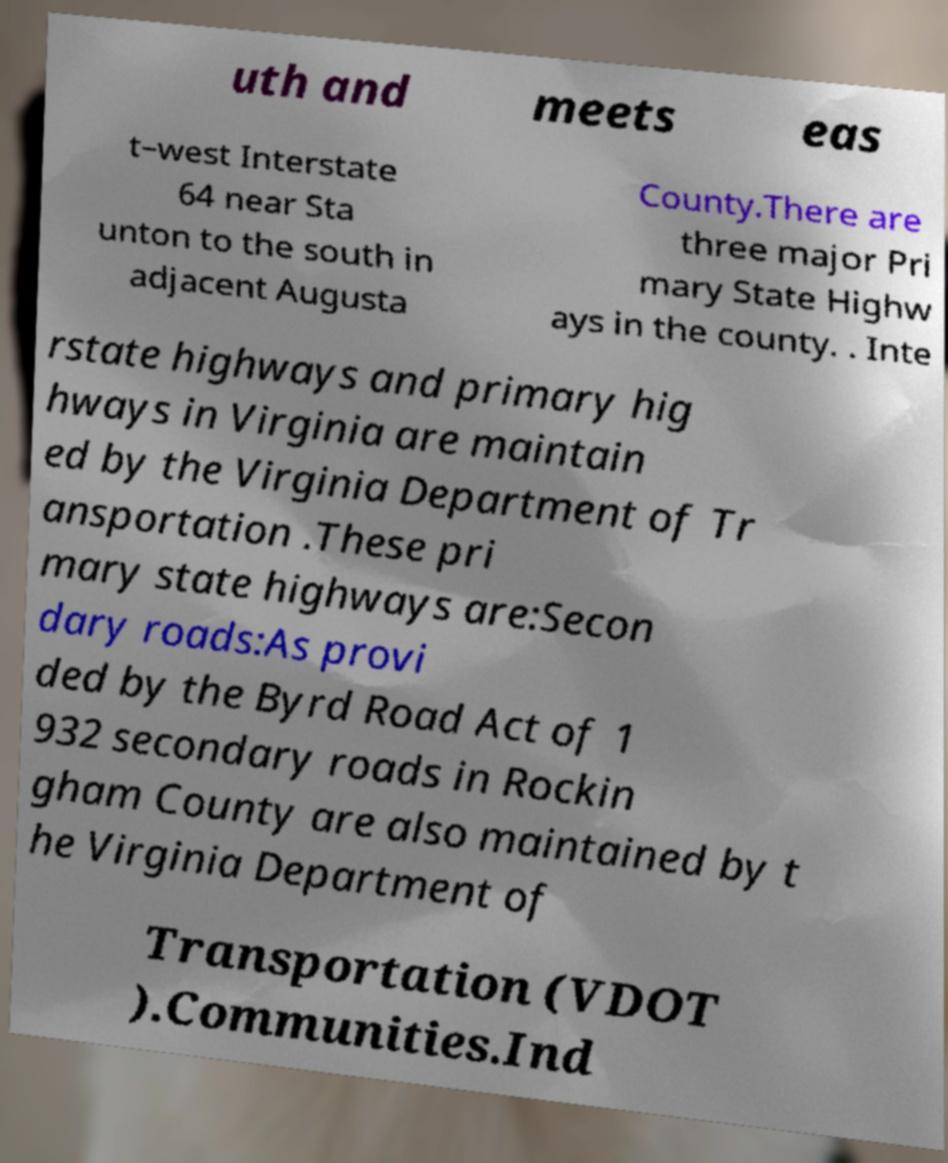Could you extract and type out the text from this image? uth and meets eas t–west Interstate 64 near Sta unton to the south in adjacent Augusta County.There are three major Pri mary State Highw ays in the county. . Inte rstate highways and primary hig hways in Virginia are maintain ed by the Virginia Department of Tr ansportation .These pri mary state highways are:Secon dary roads:As provi ded by the Byrd Road Act of 1 932 secondary roads in Rockin gham County are also maintained by t he Virginia Department of Transportation (VDOT ).Communities.Ind 